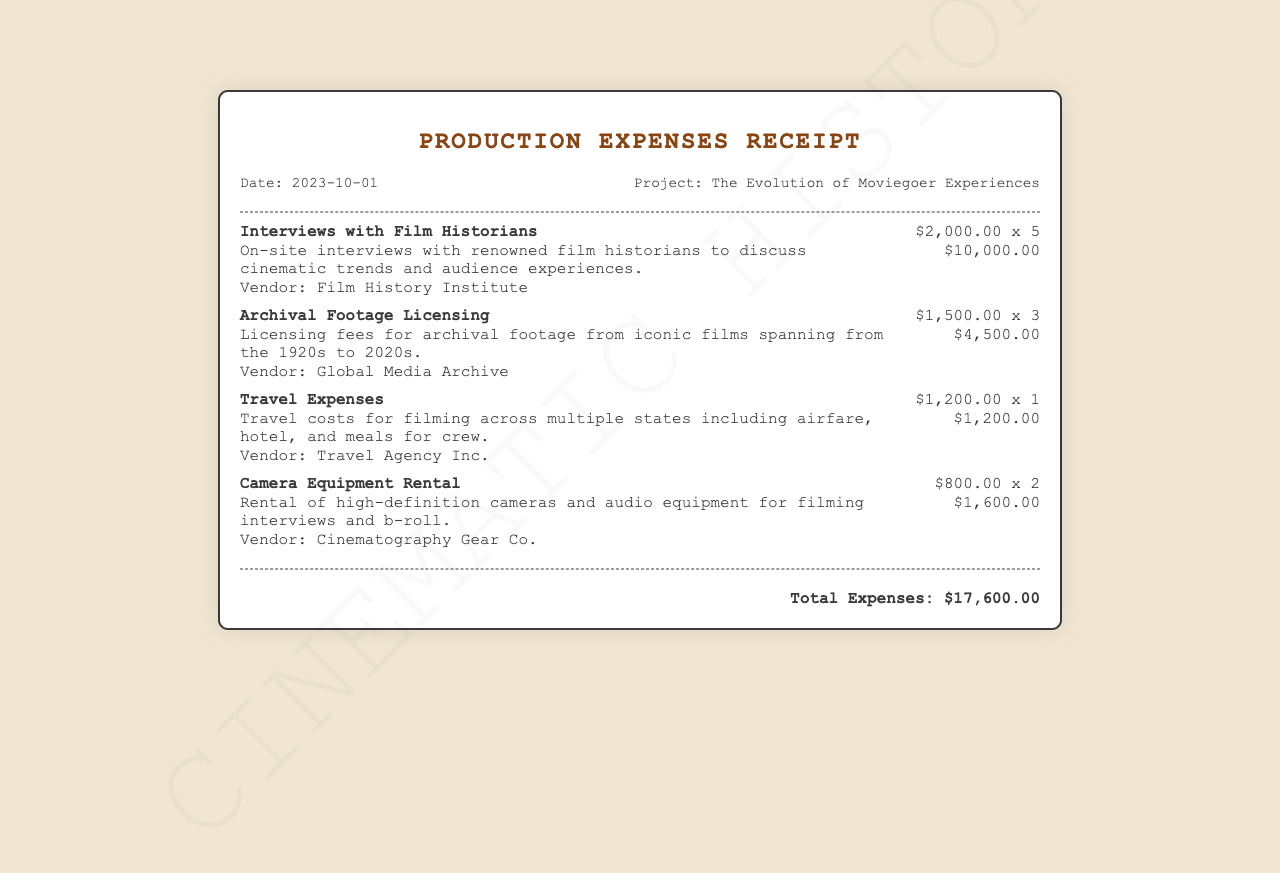what is the date of the receipt? The date of the receipt is mentioned in the header section, indicating when the expenses were recorded.
Answer: 2023-10-01 what is the total amount of expenses? The total expenses are calculated at the end of the document, summarizing all the costs listed.
Answer: $17,600.00 how many interviews with film historians were conducted? The number of interviews is specified alongside the cost per interview, indicating a total number.
Answer: 5 who is the vendor for archival footage licensing? The vendor associated with the archival footage licensing is listed with the specific item.
Answer: Global Media Archive what was the cost for travel expenses? The cost for travel expenses is detailed in the expense item line, providing insight into specific expenses.
Answer: $1,200.00 how many items were charged for camera equipment rental? The number of items rented is indicated in the expense details for camera equipment rental.
Answer: 2 what is the purpose of the documentary project? The purpose of the documentary project is outlined in the project title, indicating its focus.
Answer: The Evolution of Moviegoer Experiences what is the cost per interview with film historians? The cost for each interview is detailed alongside the total amount and quantity.
Answer: $2,000.00 who is the vendor for camera equipment rental? The vendor associated with the camera equipment rental is provided in the expense details.
Answer: Cinematography Gear Co 